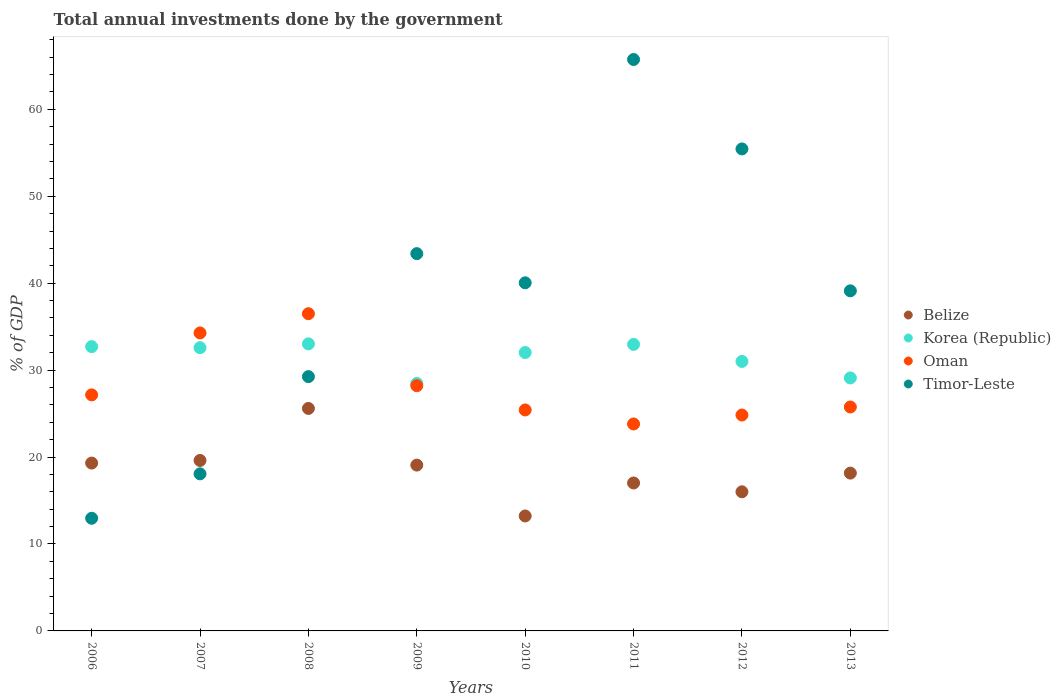What is the total annual investments done by the government in Korea (Republic) in 2007?
Provide a short and direct response. 32.58. Across all years, what is the maximum total annual investments done by the government in Belize?
Your answer should be very brief. 25.59. Across all years, what is the minimum total annual investments done by the government in Belize?
Your answer should be compact. 13.22. In which year was the total annual investments done by the government in Timor-Leste minimum?
Your answer should be compact. 2006. What is the total total annual investments done by the government in Belize in the graph?
Provide a succinct answer. 147.98. What is the difference between the total annual investments done by the government in Belize in 2006 and that in 2010?
Offer a very short reply. 6.08. What is the difference between the total annual investments done by the government in Timor-Leste in 2013 and the total annual investments done by the government in Korea (Republic) in 2009?
Provide a succinct answer. 10.65. What is the average total annual investments done by the government in Korea (Republic) per year?
Give a very brief answer. 31.48. In the year 2011, what is the difference between the total annual investments done by the government in Oman and total annual investments done by the government in Timor-Leste?
Keep it short and to the point. -41.92. In how many years, is the total annual investments done by the government in Belize greater than 24 %?
Provide a succinct answer. 1. What is the ratio of the total annual investments done by the government in Oman in 2010 to that in 2013?
Your answer should be compact. 0.99. Is the total annual investments done by the government in Korea (Republic) in 2012 less than that in 2013?
Your response must be concise. No. Is the difference between the total annual investments done by the government in Oman in 2009 and 2011 greater than the difference between the total annual investments done by the government in Timor-Leste in 2009 and 2011?
Your answer should be very brief. Yes. What is the difference between the highest and the second highest total annual investments done by the government in Timor-Leste?
Keep it short and to the point. 10.29. What is the difference between the highest and the lowest total annual investments done by the government in Timor-Leste?
Offer a terse response. 52.77. Is the total annual investments done by the government in Oman strictly greater than the total annual investments done by the government in Timor-Leste over the years?
Your answer should be compact. No. How many dotlines are there?
Your answer should be very brief. 4. Does the graph contain any zero values?
Ensure brevity in your answer.  No. How are the legend labels stacked?
Your answer should be compact. Vertical. What is the title of the graph?
Ensure brevity in your answer.  Total annual investments done by the government. Does "Sub-Saharan Africa (all income levels)" appear as one of the legend labels in the graph?
Ensure brevity in your answer.  No. What is the label or title of the X-axis?
Your answer should be compact. Years. What is the label or title of the Y-axis?
Offer a terse response. % of GDP. What is the % of GDP in Belize in 2006?
Make the answer very short. 19.31. What is the % of GDP of Korea (Republic) in 2006?
Your answer should be very brief. 32.7. What is the % of GDP of Oman in 2006?
Provide a short and direct response. 27.15. What is the % of GDP in Timor-Leste in 2006?
Give a very brief answer. 12.96. What is the % of GDP of Belize in 2007?
Provide a short and direct response. 19.61. What is the % of GDP of Korea (Republic) in 2007?
Your answer should be compact. 32.58. What is the % of GDP in Oman in 2007?
Your answer should be very brief. 34.28. What is the % of GDP of Timor-Leste in 2007?
Provide a succinct answer. 18.07. What is the % of GDP in Belize in 2008?
Offer a very short reply. 25.59. What is the % of GDP in Korea (Republic) in 2008?
Your response must be concise. 33.02. What is the % of GDP in Oman in 2008?
Give a very brief answer. 36.49. What is the % of GDP of Timor-Leste in 2008?
Make the answer very short. 29.25. What is the % of GDP in Belize in 2009?
Your answer should be very brief. 19.08. What is the % of GDP of Korea (Republic) in 2009?
Give a very brief answer. 28.47. What is the % of GDP of Oman in 2009?
Offer a very short reply. 28.21. What is the % of GDP in Timor-Leste in 2009?
Keep it short and to the point. 43.4. What is the % of GDP in Belize in 2010?
Provide a succinct answer. 13.22. What is the % of GDP in Korea (Republic) in 2010?
Keep it short and to the point. 32.02. What is the % of GDP of Oman in 2010?
Your answer should be very brief. 25.42. What is the % of GDP of Timor-Leste in 2010?
Provide a short and direct response. 40.04. What is the % of GDP in Belize in 2011?
Provide a short and direct response. 17.02. What is the % of GDP in Korea (Republic) in 2011?
Provide a succinct answer. 32.96. What is the % of GDP of Oman in 2011?
Ensure brevity in your answer.  23.8. What is the % of GDP of Timor-Leste in 2011?
Ensure brevity in your answer.  65.73. What is the % of GDP of Belize in 2012?
Make the answer very short. 16. What is the % of GDP of Korea (Republic) in 2012?
Give a very brief answer. 31. What is the % of GDP in Oman in 2012?
Give a very brief answer. 24.83. What is the % of GDP of Timor-Leste in 2012?
Your answer should be very brief. 55.44. What is the % of GDP of Belize in 2013?
Your answer should be very brief. 18.15. What is the % of GDP in Korea (Republic) in 2013?
Provide a short and direct response. 29.1. What is the % of GDP of Oman in 2013?
Offer a terse response. 25.76. What is the % of GDP of Timor-Leste in 2013?
Your answer should be very brief. 39.12. Across all years, what is the maximum % of GDP in Belize?
Your answer should be very brief. 25.59. Across all years, what is the maximum % of GDP of Korea (Republic)?
Keep it short and to the point. 33.02. Across all years, what is the maximum % of GDP of Oman?
Your answer should be very brief. 36.49. Across all years, what is the maximum % of GDP of Timor-Leste?
Your answer should be compact. 65.73. Across all years, what is the minimum % of GDP in Belize?
Offer a very short reply. 13.22. Across all years, what is the minimum % of GDP of Korea (Republic)?
Your answer should be very brief. 28.47. Across all years, what is the minimum % of GDP in Oman?
Keep it short and to the point. 23.8. Across all years, what is the minimum % of GDP in Timor-Leste?
Give a very brief answer. 12.96. What is the total % of GDP of Belize in the graph?
Your answer should be compact. 147.98. What is the total % of GDP in Korea (Republic) in the graph?
Ensure brevity in your answer.  251.85. What is the total % of GDP of Oman in the graph?
Your response must be concise. 225.94. What is the total % of GDP of Timor-Leste in the graph?
Ensure brevity in your answer.  304.01. What is the difference between the % of GDP in Belize in 2006 and that in 2007?
Ensure brevity in your answer.  -0.3. What is the difference between the % of GDP in Korea (Republic) in 2006 and that in 2007?
Offer a terse response. 0.12. What is the difference between the % of GDP of Oman in 2006 and that in 2007?
Your response must be concise. -7.13. What is the difference between the % of GDP in Timor-Leste in 2006 and that in 2007?
Your answer should be very brief. -5.11. What is the difference between the % of GDP in Belize in 2006 and that in 2008?
Offer a very short reply. -6.28. What is the difference between the % of GDP of Korea (Republic) in 2006 and that in 2008?
Your answer should be compact. -0.32. What is the difference between the % of GDP in Oman in 2006 and that in 2008?
Offer a very short reply. -9.34. What is the difference between the % of GDP in Timor-Leste in 2006 and that in 2008?
Your response must be concise. -16.29. What is the difference between the % of GDP of Belize in 2006 and that in 2009?
Your answer should be very brief. 0.23. What is the difference between the % of GDP in Korea (Republic) in 2006 and that in 2009?
Make the answer very short. 4.24. What is the difference between the % of GDP in Oman in 2006 and that in 2009?
Your answer should be very brief. -1.06. What is the difference between the % of GDP of Timor-Leste in 2006 and that in 2009?
Ensure brevity in your answer.  -30.44. What is the difference between the % of GDP in Belize in 2006 and that in 2010?
Ensure brevity in your answer.  6.08. What is the difference between the % of GDP of Korea (Republic) in 2006 and that in 2010?
Provide a succinct answer. 0.68. What is the difference between the % of GDP of Oman in 2006 and that in 2010?
Keep it short and to the point. 1.73. What is the difference between the % of GDP in Timor-Leste in 2006 and that in 2010?
Ensure brevity in your answer.  -27.08. What is the difference between the % of GDP of Belize in 2006 and that in 2011?
Provide a succinct answer. 2.29. What is the difference between the % of GDP in Korea (Republic) in 2006 and that in 2011?
Your response must be concise. -0.26. What is the difference between the % of GDP of Oman in 2006 and that in 2011?
Provide a succinct answer. 3.35. What is the difference between the % of GDP of Timor-Leste in 2006 and that in 2011?
Keep it short and to the point. -52.77. What is the difference between the % of GDP of Belize in 2006 and that in 2012?
Make the answer very short. 3.31. What is the difference between the % of GDP in Korea (Republic) in 2006 and that in 2012?
Offer a very short reply. 1.7. What is the difference between the % of GDP in Oman in 2006 and that in 2012?
Give a very brief answer. 2.32. What is the difference between the % of GDP of Timor-Leste in 2006 and that in 2012?
Keep it short and to the point. -42.49. What is the difference between the % of GDP of Belize in 2006 and that in 2013?
Offer a terse response. 1.15. What is the difference between the % of GDP in Korea (Republic) in 2006 and that in 2013?
Provide a short and direct response. 3.6. What is the difference between the % of GDP in Oman in 2006 and that in 2013?
Offer a terse response. 1.39. What is the difference between the % of GDP of Timor-Leste in 2006 and that in 2013?
Make the answer very short. -26.16. What is the difference between the % of GDP of Belize in 2007 and that in 2008?
Offer a very short reply. -5.98. What is the difference between the % of GDP in Korea (Republic) in 2007 and that in 2008?
Make the answer very short. -0.44. What is the difference between the % of GDP in Oman in 2007 and that in 2008?
Offer a terse response. -2.21. What is the difference between the % of GDP in Timor-Leste in 2007 and that in 2008?
Offer a very short reply. -11.18. What is the difference between the % of GDP in Belize in 2007 and that in 2009?
Offer a very short reply. 0.53. What is the difference between the % of GDP of Korea (Republic) in 2007 and that in 2009?
Provide a short and direct response. 4.11. What is the difference between the % of GDP in Oman in 2007 and that in 2009?
Keep it short and to the point. 6.07. What is the difference between the % of GDP in Timor-Leste in 2007 and that in 2009?
Provide a succinct answer. -25.33. What is the difference between the % of GDP of Belize in 2007 and that in 2010?
Offer a very short reply. 6.39. What is the difference between the % of GDP of Korea (Republic) in 2007 and that in 2010?
Provide a succinct answer. 0.56. What is the difference between the % of GDP in Oman in 2007 and that in 2010?
Ensure brevity in your answer.  8.86. What is the difference between the % of GDP in Timor-Leste in 2007 and that in 2010?
Provide a short and direct response. -21.97. What is the difference between the % of GDP of Belize in 2007 and that in 2011?
Provide a short and direct response. 2.59. What is the difference between the % of GDP in Korea (Republic) in 2007 and that in 2011?
Your response must be concise. -0.38. What is the difference between the % of GDP of Oman in 2007 and that in 2011?
Ensure brevity in your answer.  10.47. What is the difference between the % of GDP of Timor-Leste in 2007 and that in 2011?
Offer a very short reply. -47.66. What is the difference between the % of GDP of Belize in 2007 and that in 2012?
Your answer should be very brief. 3.61. What is the difference between the % of GDP of Korea (Republic) in 2007 and that in 2012?
Ensure brevity in your answer.  1.58. What is the difference between the % of GDP in Oman in 2007 and that in 2012?
Provide a succinct answer. 9.44. What is the difference between the % of GDP of Timor-Leste in 2007 and that in 2012?
Your answer should be compact. -37.38. What is the difference between the % of GDP of Belize in 2007 and that in 2013?
Your response must be concise. 1.45. What is the difference between the % of GDP of Korea (Republic) in 2007 and that in 2013?
Ensure brevity in your answer.  3.48. What is the difference between the % of GDP in Oman in 2007 and that in 2013?
Offer a very short reply. 8.52. What is the difference between the % of GDP of Timor-Leste in 2007 and that in 2013?
Ensure brevity in your answer.  -21.05. What is the difference between the % of GDP of Belize in 2008 and that in 2009?
Your answer should be compact. 6.52. What is the difference between the % of GDP in Korea (Republic) in 2008 and that in 2009?
Provide a short and direct response. 4.55. What is the difference between the % of GDP of Oman in 2008 and that in 2009?
Provide a succinct answer. 8.28. What is the difference between the % of GDP of Timor-Leste in 2008 and that in 2009?
Provide a short and direct response. -14.15. What is the difference between the % of GDP of Belize in 2008 and that in 2010?
Your answer should be compact. 12.37. What is the difference between the % of GDP in Korea (Republic) in 2008 and that in 2010?
Offer a terse response. 1. What is the difference between the % of GDP of Oman in 2008 and that in 2010?
Your response must be concise. 11.07. What is the difference between the % of GDP in Timor-Leste in 2008 and that in 2010?
Your answer should be very brief. -10.79. What is the difference between the % of GDP of Belize in 2008 and that in 2011?
Offer a terse response. 8.57. What is the difference between the % of GDP in Korea (Republic) in 2008 and that in 2011?
Provide a short and direct response. 0.06. What is the difference between the % of GDP of Oman in 2008 and that in 2011?
Keep it short and to the point. 12.68. What is the difference between the % of GDP of Timor-Leste in 2008 and that in 2011?
Your answer should be compact. -36.48. What is the difference between the % of GDP in Belize in 2008 and that in 2012?
Give a very brief answer. 9.59. What is the difference between the % of GDP in Korea (Republic) in 2008 and that in 2012?
Ensure brevity in your answer.  2.02. What is the difference between the % of GDP in Oman in 2008 and that in 2012?
Make the answer very short. 11.65. What is the difference between the % of GDP of Timor-Leste in 2008 and that in 2012?
Provide a short and direct response. -26.19. What is the difference between the % of GDP of Belize in 2008 and that in 2013?
Ensure brevity in your answer.  7.44. What is the difference between the % of GDP in Korea (Republic) in 2008 and that in 2013?
Keep it short and to the point. 3.92. What is the difference between the % of GDP in Oman in 2008 and that in 2013?
Keep it short and to the point. 10.73. What is the difference between the % of GDP of Timor-Leste in 2008 and that in 2013?
Keep it short and to the point. -9.87. What is the difference between the % of GDP of Belize in 2009 and that in 2010?
Offer a very short reply. 5.85. What is the difference between the % of GDP in Korea (Republic) in 2009 and that in 2010?
Your answer should be compact. -3.56. What is the difference between the % of GDP in Oman in 2009 and that in 2010?
Keep it short and to the point. 2.79. What is the difference between the % of GDP of Timor-Leste in 2009 and that in 2010?
Your response must be concise. 3.36. What is the difference between the % of GDP in Belize in 2009 and that in 2011?
Make the answer very short. 2.06. What is the difference between the % of GDP in Korea (Republic) in 2009 and that in 2011?
Make the answer very short. -4.49. What is the difference between the % of GDP of Oman in 2009 and that in 2011?
Offer a terse response. 4.4. What is the difference between the % of GDP in Timor-Leste in 2009 and that in 2011?
Provide a short and direct response. -22.33. What is the difference between the % of GDP in Belize in 2009 and that in 2012?
Make the answer very short. 3.07. What is the difference between the % of GDP in Korea (Republic) in 2009 and that in 2012?
Your answer should be very brief. -2.54. What is the difference between the % of GDP of Oman in 2009 and that in 2012?
Your answer should be very brief. 3.37. What is the difference between the % of GDP of Timor-Leste in 2009 and that in 2012?
Keep it short and to the point. -12.05. What is the difference between the % of GDP in Belize in 2009 and that in 2013?
Provide a short and direct response. 0.92. What is the difference between the % of GDP in Korea (Republic) in 2009 and that in 2013?
Keep it short and to the point. -0.64. What is the difference between the % of GDP of Oman in 2009 and that in 2013?
Make the answer very short. 2.45. What is the difference between the % of GDP of Timor-Leste in 2009 and that in 2013?
Give a very brief answer. 4.28. What is the difference between the % of GDP in Belize in 2010 and that in 2011?
Provide a short and direct response. -3.8. What is the difference between the % of GDP of Korea (Republic) in 2010 and that in 2011?
Your answer should be very brief. -0.94. What is the difference between the % of GDP of Oman in 2010 and that in 2011?
Provide a short and direct response. 1.61. What is the difference between the % of GDP in Timor-Leste in 2010 and that in 2011?
Offer a very short reply. -25.69. What is the difference between the % of GDP in Belize in 2010 and that in 2012?
Provide a succinct answer. -2.78. What is the difference between the % of GDP of Korea (Republic) in 2010 and that in 2012?
Offer a terse response. 1.02. What is the difference between the % of GDP of Oman in 2010 and that in 2012?
Provide a succinct answer. 0.58. What is the difference between the % of GDP in Timor-Leste in 2010 and that in 2012?
Keep it short and to the point. -15.4. What is the difference between the % of GDP in Belize in 2010 and that in 2013?
Offer a terse response. -4.93. What is the difference between the % of GDP of Korea (Republic) in 2010 and that in 2013?
Make the answer very short. 2.92. What is the difference between the % of GDP of Oman in 2010 and that in 2013?
Give a very brief answer. -0.34. What is the difference between the % of GDP of Timor-Leste in 2010 and that in 2013?
Keep it short and to the point. 0.92. What is the difference between the % of GDP in Belize in 2011 and that in 2012?
Ensure brevity in your answer.  1.02. What is the difference between the % of GDP in Korea (Republic) in 2011 and that in 2012?
Your response must be concise. 1.96. What is the difference between the % of GDP of Oman in 2011 and that in 2012?
Keep it short and to the point. -1.03. What is the difference between the % of GDP in Timor-Leste in 2011 and that in 2012?
Ensure brevity in your answer.  10.29. What is the difference between the % of GDP of Belize in 2011 and that in 2013?
Ensure brevity in your answer.  -1.14. What is the difference between the % of GDP of Korea (Republic) in 2011 and that in 2013?
Offer a very short reply. 3.86. What is the difference between the % of GDP in Oman in 2011 and that in 2013?
Provide a succinct answer. -1.95. What is the difference between the % of GDP of Timor-Leste in 2011 and that in 2013?
Your answer should be very brief. 26.61. What is the difference between the % of GDP of Belize in 2012 and that in 2013?
Provide a succinct answer. -2.15. What is the difference between the % of GDP in Korea (Republic) in 2012 and that in 2013?
Keep it short and to the point. 1.9. What is the difference between the % of GDP of Oman in 2012 and that in 2013?
Ensure brevity in your answer.  -0.93. What is the difference between the % of GDP in Timor-Leste in 2012 and that in 2013?
Your answer should be very brief. 16.32. What is the difference between the % of GDP in Belize in 2006 and the % of GDP in Korea (Republic) in 2007?
Keep it short and to the point. -13.27. What is the difference between the % of GDP in Belize in 2006 and the % of GDP in Oman in 2007?
Offer a terse response. -14.97. What is the difference between the % of GDP in Belize in 2006 and the % of GDP in Timor-Leste in 2007?
Your answer should be very brief. 1.24. What is the difference between the % of GDP of Korea (Republic) in 2006 and the % of GDP of Oman in 2007?
Your response must be concise. -1.58. What is the difference between the % of GDP of Korea (Republic) in 2006 and the % of GDP of Timor-Leste in 2007?
Provide a succinct answer. 14.63. What is the difference between the % of GDP of Oman in 2006 and the % of GDP of Timor-Leste in 2007?
Provide a succinct answer. 9.08. What is the difference between the % of GDP of Belize in 2006 and the % of GDP of Korea (Republic) in 2008?
Your response must be concise. -13.71. What is the difference between the % of GDP in Belize in 2006 and the % of GDP in Oman in 2008?
Offer a terse response. -17.18. What is the difference between the % of GDP of Belize in 2006 and the % of GDP of Timor-Leste in 2008?
Offer a terse response. -9.94. What is the difference between the % of GDP of Korea (Republic) in 2006 and the % of GDP of Oman in 2008?
Your answer should be very brief. -3.79. What is the difference between the % of GDP of Korea (Republic) in 2006 and the % of GDP of Timor-Leste in 2008?
Keep it short and to the point. 3.45. What is the difference between the % of GDP of Oman in 2006 and the % of GDP of Timor-Leste in 2008?
Provide a short and direct response. -2.1. What is the difference between the % of GDP in Belize in 2006 and the % of GDP in Korea (Republic) in 2009?
Make the answer very short. -9.16. What is the difference between the % of GDP in Belize in 2006 and the % of GDP in Oman in 2009?
Your answer should be compact. -8.9. What is the difference between the % of GDP in Belize in 2006 and the % of GDP in Timor-Leste in 2009?
Provide a short and direct response. -24.09. What is the difference between the % of GDP of Korea (Republic) in 2006 and the % of GDP of Oman in 2009?
Give a very brief answer. 4.49. What is the difference between the % of GDP of Korea (Republic) in 2006 and the % of GDP of Timor-Leste in 2009?
Keep it short and to the point. -10.7. What is the difference between the % of GDP in Oman in 2006 and the % of GDP in Timor-Leste in 2009?
Your answer should be compact. -16.25. What is the difference between the % of GDP of Belize in 2006 and the % of GDP of Korea (Republic) in 2010?
Give a very brief answer. -12.71. What is the difference between the % of GDP of Belize in 2006 and the % of GDP of Oman in 2010?
Ensure brevity in your answer.  -6.11. What is the difference between the % of GDP of Belize in 2006 and the % of GDP of Timor-Leste in 2010?
Provide a short and direct response. -20.73. What is the difference between the % of GDP in Korea (Republic) in 2006 and the % of GDP in Oman in 2010?
Offer a very short reply. 7.28. What is the difference between the % of GDP of Korea (Republic) in 2006 and the % of GDP of Timor-Leste in 2010?
Give a very brief answer. -7.34. What is the difference between the % of GDP of Oman in 2006 and the % of GDP of Timor-Leste in 2010?
Offer a very short reply. -12.89. What is the difference between the % of GDP of Belize in 2006 and the % of GDP of Korea (Republic) in 2011?
Keep it short and to the point. -13.65. What is the difference between the % of GDP of Belize in 2006 and the % of GDP of Oman in 2011?
Make the answer very short. -4.5. What is the difference between the % of GDP in Belize in 2006 and the % of GDP in Timor-Leste in 2011?
Provide a short and direct response. -46.42. What is the difference between the % of GDP in Korea (Republic) in 2006 and the % of GDP in Oman in 2011?
Offer a very short reply. 8.9. What is the difference between the % of GDP in Korea (Republic) in 2006 and the % of GDP in Timor-Leste in 2011?
Offer a very short reply. -33.03. What is the difference between the % of GDP of Oman in 2006 and the % of GDP of Timor-Leste in 2011?
Provide a succinct answer. -38.58. What is the difference between the % of GDP in Belize in 2006 and the % of GDP in Korea (Republic) in 2012?
Provide a succinct answer. -11.69. What is the difference between the % of GDP in Belize in 2006 and the % of GDP in Oman in 2012?
Provide a succinct answer. -5.53. What is the difference between the % of GDP of Belize in 2006 and the % of GDP of Timor-Leste in 2012?
Offer a very short reply. -36.14. What is the difference between the % of GDP of Korea (Republic) in 2006 and the % of GDP of Oman in 2012?
Provide a short and direct response. 7.87. What is the difference between the % of GDP of Korea (Republic) in 2006 and the % of GDP of Timor-Leste in 2012?
Give a very brief answer. -22.74. What is the difference between the % of GDP of Oman in 2006 and the % of GDP of Timor-Leste in 2012?
Provide a succinct answer. -28.29. What is the difference between the % of GDP in Belize in 2006 and the % of GDP in Korea (Republic) in 2013?
Give a very brief answer. -9.79. What is the difference between the % of GDP in Belize in 2006 and the % of GDP in Oman in 2013?
Give a very brief answer. -6.45. What is the difference between the % of GDP of Belize in 2006 and the % of GDP of Timor-Leste in 2013?
Provide a short and direct response. -19.81. What is the difference between the % of GDP in Korea (Republic) in 2006 and the % of GDP in Oman in 2013?
Provide a succinct answer. 6.94. What is the difference between the % of GDP in Korea (Republic) in 2006 and the % of GDP in Timor-Leste in 2013?
Your answer should be very brief. -6.42. What is the difference between the % of GDP of Oman in 2006 and the % of GDP of Timor-Leste in 2013?
Your answer should be compact. -11.97. What is the difference between the % of GDP in Belize in 2007 and the % of GDP in Korea (Republic) in 2008?
Your response must be concise. -13.41. What is the difference between the % of GDP of Belize in 2007 and the % of GDP of Oman in 2008?
Ensure brevity in your answer.  -16.88. What is the difference between the % of GDP of Belize in 2007 and the % of GDP of Timor-Leste in 2008?
Your response must be concise. -9.64. What is the difference between the % of GDP in Korea (Republic) in 2007 and the % of GDP in Oman in 2008?
Ensure brevity in your answer.  -3.91. What is the difference between the % of GDP in Korea (Republic) in 2007 and the % of GDP in Timor-Leste in 2008?
Provide a short and direct response. 3.33. What is the difference between the % of GDP in Oman in 2007 and the % of GDP in Timor-Leste in 2008?
Your answer should be very brief. 5.03. What is the difference between the % of GDP of Belize in 2007 and the % of GDP of Korea (Republic) in 2009?
Provide a succinct answer. -8.86. What is the difference between the % of GDP of Belize in 2007 and the % of GDP of Oman in 2009?
Offer a terse response. -8.6. What is the difference between the % of GDP of Belize in 2007 and the % of GDP of Timor-Leste in 2009?
Offer a terse response. -23.79. What is the difference between the % of GDP in Korea (Republic) in 2007 and the % of GDP in Oman in 2009?
Your answer should be very brief. 4.37. What is the difference between the % of GDP in Korea (Republic) in 2007 and the % of GDP in Timor-Leste in 2009?
Keep it short and to the point. -10.82. What is the difference between the % of GDP of Oman in 2007 and the % of GDP of Timor-Leste in 2009?
Make the answer very short. -9.12. What is the difference between the % of GDP in Belize in 2007 and the % of GDP in Korea (Republic) in 2010?
Offer a very short reply. -12.41. What is the difference between the % of GDP in Belize in 2007 and the % of GDP in Oman in 2010?
Make the answer very short. -5.81. What is the difference between the % of GDP of Belize in 2007 and the % of GDP of Timor-Leste in 2010?
Ensure brevity in your answer.  -20.43. What is the difference between the % of GDP in Korea (Republic) in 2007 and the % of GDP in Oman in 2010?
Ensure brevity in your answer.  7.16. What is the difference between the % of GDP in Korea (Republic) in 2007 and the % of GDP in Timor-Leste in 2010?
Your answer should be compact. -7.46. What is the difference between the % of GDP in Oman in 2007 and the % of GDP in Timor-Leste in 2010?
Your answer should be very brief. -5.77. What is the difference between the % of GDP in Belize in 2007 and the % of GDP in Korea (Republic) in 2011?
Provide a short and direct response. -13.35. What is the difference between the % of GDP of Belize in 2007 and the % of GDP of Oman in 2011?
Give a very brief answer. -4.2. What is the difference between the % of GDP of Belize in 2007 and the % of GDP of Timor-Leste in 2011?
Ensure brevity in your answer.  -46.12. What is the difference between the % of GDP in Korea (Republic) in 2007 and the % of GDP in Oman in 2011?
Provide a succinct answer. 8.77. What is the difference between the % of GDP in Korea (Republic) in 2007 and the % of GDP in Timor-Leste in 2011?
Provide a succinct answer. -33.15. What is the difference between the % of GDP of Oman in 2007 and the % of GDP of Timor-Leste in 2011?
Your answer should be compact. -31.45. What is the difference between the % of GDP in Belize in 2007 and the % of GDP in Korea (Republic) in 2012?
Provide a succinct answer. -11.39. What is the difference between the % of GDP of Belize in 2007 and the % of GDP of Oman in 2012?
Your response must be concise. -5.23. What is the difference between the % of GDP of Belize in 2007 and the % of GDP of Timor-Leste in 2012?
Your answer should be very brief. -35.84. What is the difference between the % of GDP in Korea (Republic) in 2007 and the % of GDP in Oman in 2012?
Provide a short and direct response. 7.75. What is the difference between the % of GDP in Korea (Republic) in 2007 and the % of GDP in Timor-Leste in 2012?
Your response must be concise. -22.86. What is the difference between the % of GDP of Oman in 2007 and the % of GDP of Timor-Leste in 2012?
Offer a terse response. -21.17. What is the difference between the % of GDP of Belize in 2007 and the % of GDP of Korea (Republic) in 2013?
Provide a succinct answer. -9.49. What is the difference between the % of GDP in Belize in 2007 and the % of GDP in Oman in 2013?
Give a very brief answer. -6.15. What is the difference between the % of GDP of Belize in 2007 and the % of GDP of Timor-Leste in 2013?
Provide a succinct answer. -19.51. What is the difference between the % of GDP in Korea (Republic) in 2007 and the % of GDP in Oman in 2013?
Your response must be concise. 6.82. What is the difference between the % of GDP of Korea (Republic) in 2007 and the % of GDP of Timor-Leste in 2013?
Offer a terse response. -6.54. What is the difference between the % of GDP of Oman in 2007 and the % of GDP of Timor-Leste in 2013?
Ensure brevity in your answer.  -4.84. What is the difference between the % of GDP of Belize in 2008 and the % of GDP of Korea (Republic) in 2009?
Your answer should be compact. -2.87. What is the difference between the % of GDP of Belize in 2008 and the % of GDP of Oman in 2009?
Offer a terse response. -2.61. What is the difference between the % of GDP in Belize in 2008 and the % of GDP in Timor-Leste in 2009?
Offer a terse response. -17.81. What is the difference between the % of GDP in Korea (Republic) in 2008 and the % of GDP in Oman in 2009?
Offer a very short reply. 4.81. What is the difference between the % of GDP in Korea (Republic) in 2008 and the % of GDP in Timor-Leste in 2009?
Your answer should be compact. -10.38. What is the difference between the % of GDP in Oman in 2008 and the % of GDP in Timor-Leste in 2009?
Ensure brevity in your answer.  -6.91. What is the difference between the % of GDP in Belize in 2008 and the % of GDP in Korea (Republic) in 2010?
Keep it short and to the point. -6.43. What is the difference between the % of GDP in Belize in 2008 and the % of GDP in Oman in 2010?
Your response must be concise. 0.17. What is the difference between the % of GDP of Belize in 2008 and the % of GDP of Timor-Leste in 2010?
Provide a succinct answer. -14.45. What is the difference between the % of GDP in Korea (Republic) in 2008 and the % of GDP in Oman in 2010?
Your answer should be compact. 7.6. What is the difference between the % of GDP of Korea (Republic) in 2008 and the % of GDP of Timor-Leste in 2010?
Ensure brevity in your answer.  -7.02. What is the difference between the % of GDP of Oman in 2008 and the % of GDP of Timor-Leste in 2010?
Your response must be concise. -3.55. What is the difference between the % of GDP in Belize in 2008 and the % of GDP in Korea (Republic) in 2011?
Make the answer very short. -7.37. What is the difference between the % of GDP of Belize in 2008 and the % of GDP of Oman in 2011?
Give a very brief answer. 1.79. What is the difference between the % of GDP in Belize in 2008 and the % of GDP in Timor-Leste in 2011?
Your response must be concise. -40.14. What is the difference between the % of GDP of Korea (Republic) in 2008 and the % of GDP of Oman in 2011?
Your answer should be compact. 9.21. What is the difference between the % of GDP in Korea (Republic) in 2008 and the % of GDP in Timor-Leste in 2011?
Offer a terse response. -32.71. What is the difference between the % of GDP in Oman in 2008 and the % of GDP in Timor-Leste in 2011?
Your response must be concise. -29.24. What is the difference between the % of GDP of Belize in 2008 and the % of GDP of Korea (Republic) in 2012?
Keep it short and to the point. -5.41. What is the difference between the % of GDP of Belize in 2008 and the % of GDP of Oman in 2012?
Offer a very short reply. 0.76. What is the difference between the % of GDP in Belize in 2008 and the % of GDP in Timor-Leste in 2012?
Give a very brief answer. -29.85. What is the difference between the % of GDP of Korea (Republic) in 2008 and the % of GDP of Oman in 2012?
Your response must be concise. 8.18. What is the difference between the % of GDP of Korea (Republic) in 2008 and the % of GDP of Timor-Leste in 2012?
Provide a succinct answer. -22.43. What is the difference between the % of GDP in Oman in 2008 and the % of GDP in Timor-Leste in 2012?
Make the answer very short. -18.96. What is the difference between the % of GDP in Belize in 2008 and the % of GDP in Korea (Republic) in 2013?
Make the answer very short. -3.51. What is the difference between the % of GDP in Belize in 2008 and the % of GDP in Oman in 2013?
Your answer should be compact. -0.17. What is the difference between the % of GDP in Belize in 2008 and the % of GDP in Timor-Leste in 2013?
Ensure brevity in your answer.  -13.53. What is the difference between the % of GDP of Korea (Republic) in 2008 and the % of GDP of Oman in 2013?
Ensure brevity in your answer.  7.26. What is the difference between the % of GDP of Korea (Republic) in 2008 and the % of GDP of Timor-Leste in 2013?
Your response must be concise. -6.1. What is the difference between the % of GDP of Oman in 2008 and the % of GDP of Timor-Leste in 2013?
Provide a succinct answer. -2.63. What is the difference between the % of GDP in Belize in 2009 and the % of GDP in Korea (Republic) in 2010?
Make the answer very short. -12.95. What is the difference between the % of GDP of Belize in 2009 and the % of GDP of Oman in 2010?
Your response must be concise. -6.34. What is the difference between the % of GDP in Belize in 2009 and the % of GDP in Timor-Leste in 2010?
Offer a very short reply. -20.97. What is the difference between the % of GDP in Korea (Republic) in 2009 and the % of GDP in Oman in 2010?
Provide a succinct answer. 3.05. What is the difference between the % of GDP of Korea (Republic) in 2009 and the % of GDP of Timor-Leste in 2010?
Offer a terse response. -11.58. What is the difference between the % of GDP in Oman in 2009 and the % of GDP in Timor-Leste in 2010?
Provide a short and direct response. -11.84. What is the difference between the % of GDP of Belize in 2009 and the % of GDP of Korea (Republic) in 2011?
Ensure brevity in your answer.  -13.88. What is the difference between the % of GDP in Belize in 2009 and the % of GDP in Oman in 2011?
Make the answer very short. -4.73. What is the difference between the % of GDP in Belize in 2009 and the % of GDP in Timor-Leste in 2011?
Provide a short and direct response. -46.65. What is the difference between the % of GDP in Korea (Republic) in 2009 and the % of GDP in Oman in 2011?
Your response must be concise. 4.66. What is the difference between the % of GDP in Korea (Republic) in 2009 and the % of GDP in Timor-Leste in 2011?
Your answer should be very brief. -37.26. What is the difference between the % of GDP in Oman in 2009 and the % of GDP in Timor-Leste in 2011?
Your response must be concise. -37.52. What is the difference between the % of GDP in Belize in 2009 and the % of GDP in Korea (Republic) in 2012?
Give a very brief answer. -11.93. What is the difference between the % of GDP in Belize in 2009 and the % of GDP in Oman in 2012?
Keep it short and to the point. -5.76. What is the difference between the % of GDP in Belize in 2009 and the % of GDP in Timor-Leste in 2012?
Your response must be concise. -36.37. What is the difference between the % of GDP of Korea (Republic) in 2009 and the % of GDP of Oman in 2012?
Offer a terse response. 3.63. What is the difference between the % of GDP of Korea (Republic) in 2009 and the % of GDP of Timor-Leste in 2012?
Offer a terse response. -26.98. What is the difference between the % of GDP of Oman in 2009 and the % of GDP of Timor-Leste in 2012?
Provide a short and direct response. -27.24. What is the difference between the % of GDP in Belize in 2009 and the % of GDP in Korea (Republic) in 2013?
Give a very brief answer. -10.03. What is the difference between the % of GDP in Belize in 2009 and the % of GDP in Oman in 2013?
Ensure brevity in your answer.  -6.68. What is the difference between the % of GDP in Belize in 2009 and the % of GDP in Timor-Leste in 2013?
Offer a terse response. -20.05. What is the difference between the % of GDP of Korea (Republic) in 2009 and the % of GDP of Oman in 2013?
Provide a succinct answer. 2.71. What is the difference between the % of GDP in Korea (Republic) in 2009 and the % of GDP in Timor-Leste in 2013?
Make the answer very short. -10.65. What is the difference between the % of GDP of Oman in 2009 and the % of GDP of Timor-Leste in 2013?
Your answer should be compact. -10.91. What is the difference between the % of GDP in Belize in 2010 and the % of GDP in Korea (Republic) in 2011?
Offer a terse response. -19.74. What is the difference between the % of GDP of Belize in 2010 and the % of GDP of Oman in 2011?
Make the answer very short. -10.58. What is the difference between the % of GDP in Belize in 2010 and the % of GDP in Timor-Leste in 2011?
Give a very brief answer. -52.51. What is the difference between the % of GDP of Korea (Republic) in 2010 and the % of GDP of Oman in 2011?
Ensure brevity in your answer.  8.22. What is the difference between the % of GDP of Korea (Republic) in 2010 and the % of GDP of Timor-Leste in 2011?
Give a very brief answer. -33.71. What is the difference between the % of GDP in Oman in 2010 and the % of GDP in Timor-Leste in 2011?
Your answer should be very brief. -40.31. What is the difference between the % of GDP of Belize in 2010 and the % of GDP of Korea (Republic) in 2012?
Your response must be concise. -17.78. What is the difference between the % of GDP of Belize in 2010 and the % of GDP of Oman in 2012?
Offer a terse response. -11.61. What is the difference between the % of GDP in Belize in 2010 and the % of GDP in Timor-Leste in 2012?
Ensure brevity in your answer.  -42.22. What is the difference between the % of GDP in Korea (Republic) in 2010 and the % of GDP in Oman in 2012?
Your response must be concise. 7.19. What is the difference between the % of GDP in Korea (Republic) in 2010 and the % of GDP in Timor-Leste in 2012?
Offer a terse response. -23.42. What is the difference between the % of GDP in Oman in 2010 and the % of GDP in Timor-Leste in 2012?
Provide a succinct answer. -30.03. What is the difference between the % of GDP of Belize in 2010 and the % of GDP of Korea (Republic) in 2013?
Provide a succinct answer. -15.88. What is the difference between the % of GDP in Belize in 2010 and the % of GDP in Oman in 2013?
Your response must be concise. -12.54. What is the difference between the % of GDP of Belize in 2010 and the % of GDP of Timor-Leste in 2013?
Your response must be concise. -25.9. What is the difference between the % of GDP of Korea (Republic) in 2010 and the % of GDP of Oman in 2013?
Your answer should be very brief. 6.26. What is the difference between the % of GDP of Korea (Republic) in 2010 and the % of GDP of Timor-Leste in 2013?
Your answer should be very brief. -7.1. What is the difference between the % of GDP of Oman in 2010 and the % of GDP of Timor-Leste in 2013?
Provide a short and direct response. -13.7. What is the difference between the % of GDP in Belize in 2011 and the % of GDP in Korea (Republic) in 2012?
Give a very brief answer. -13.98. What is the difference between the % of GDP of Belize in 2011 and the % of GDP of Oman in 2012?
Your answer should be compact. -7.82. What is the difference between the % of GDP in Belize in 2011 and the % of GDP in Timor-Leste in 2012?
Ensure brevity in your answer.  -38.43. What is the difference between the % of GDP in Korea (Republic) in 2011 and the % of GDP in Oman in 2012?
Offer a terse response. 8.12. What is the difference between the % of GDP of Korea (Republic) in 2011 and the % of GDP of Timor-Leste in 2012?
Provide a short and direct response. -22.49. What is the difference between the % of GDP in Oman in 2011 and the % of GDP in Timor-Leste in 2012?
Ensure brevity in your answer.  -31.64. What is the difference between the % of GDP of Belize in 2011 and the % of GDP of Korea (Republic) in 2013?
Your response must be concise. -12.08. What is the difference between the % of GDP of Belize in 2011 and the % of GDP of Oman in 2013?
Provide a short and direct response. -8.74. What is the difference between the % of GDP in Belize in 2011 and the % of GDP in Timor-Leste in 2013?
Make the answer very short. -22.1. What is the difference between the % of GDP in Korea (Republic) in 2011 and the % of GDP in Oman in 2013?
Provide a short and direct response. 7.2. What is the difference between the % of GDP in Korea (Republic) in 2011 and the % of GDP in Timor-Leste in 2013?
Offer a terse response. -6.16. What is the difference between the % of GDP of Oman in 2011 and the % of GDP of Timor-Leste in 2013?
Offer a terse response. -15.32. What is the difference between the % of GDP in Belize in 2012 and the % of GDP in Korea (Republic) in 2013?
Offer a terse response. -13.1. What is the difference between the % of GDP of Belize in 2012 and the % of GDP of Oman in 2013?
Offer a very short reply. -9.76. What is the difference between the % of GDP in Belize in 2012 and the % of GDP in Timor-Leste in 2013?
Provide a short and direct response. -23.12. What is the difference between the % of GDP of Korea (Republic) in 2012 and the % of GDP of Oman in 2013?
Provide a short and direct response. 5.24. What is the difference between the % of GDP of Korea (Republic) in 2012 and the % of GDP of Timor-Leste in 2013?
Keep it short and to the point. -8.12. What is the difference between the % of GDP in Oman in 2012 and the % of GDP in Timor-Leste in 2013?
Offer a terse response. -14.29. What is the average % of GDP of Belize per year?
Make the answer very short. 18.5. What is the average % of GDP of Korea (Republic) per year?
Keep it short and to the point. 31.48. What is the average % of GDP of Oman per year?
Provide a short and direct response. 28.24. What is the average % of GDP in Timor-Leste per year?
Ensure brevity in your answer.  38. In the year 2006, what is the difference between the % of GDP in Belize and % of GDP in Korea (Republic)?
Offer a terse response. -13.39. In the year 2006, what is the difference between the % of GDP in Belize and % of GDP in Oman?
Ensure brevity in your answer.  -7.84. In the year 2006, what is the difference between the % of GDP of Belize and % of GDP of Timor-Leste?
Provide a succinct answer. 6.35. In the year 2006, what is the difference between the % of GDP in Korea (Republic) and % of GDP in Oman?
Give a very brief answer. 5.55. In the year 2006, what is the difference between the % of GDP of Korea (Republic) and % of GDP of Timor-Leste?
Keep it short and to the point. 19.74. In the year 2006, what is the difference between the % of GDP in Oman and % of GDP in Timor-Leste?
Your answer should be compact. 14.19. In the year 2007, what is the difference between the % of GDP of Belize and % of GDP of Korea (Republic)?
Provide a succinct answer. -12.97. In the year 2007, what is the difference between the % of GDP of Belize and % of GDP of Oman?
Provide a short and direct response. -14.67. In the year 2007, what is the difference between the % of GDP in Belize and % of GDP in Timor-Leste?
Offer a very short reply. 1.54. In the year 2007, what is the difference between the % of GDP in Korea (Republic) and % of GDP in Oman?
Offer a terse response. -1.7. In the year 2007, what is the difference between the % of GDP of Korea (Republic) and % of GDP of Timor-Leste?
Your answer should be compact. 14.51. In the year 2007, what is the difference between the % of GDP of Oman and % of GDP of Timor-Leste?
Ensure brevity in your answer.  16.21. In the year 2008, what is the difference between the % of GDP in Belize and % of GDP in Korea (Republic)?
Provide a short and direct response. -7.43. In the year 2008, what is the difference between the % of GDP in Belize and % of GDP in Oman?
Make the answer very short. -10.9. In the year 2008, what is the difference between the % of GDP in Belize and % of GDP in Timor-Leste?
Give a very brief answer. -3.66. In the year 2008, what is the difference between the % of GDP of Korea (Republic) and % of GDP of Oman?
Offer a terse response. -3.47. In the year 2008, what is the difference between the % of GDP in Korea (Republic) and % of GDP in Timor-Leste?
Offer a terse response. 3.77. In the year 2008, what is the difference between the % of GDP in Oman and % of GDP in Timor-Leste?
Make the answer very short. 7.24. In the year 2009, what is the difference between the % of GDP of Belize and % of GDP of Korea (Republic)?
Keep it short and to the point. -9.39. In the year 2009, what is the difference between the % of GDP in Belize and % of GDP in Oman?
Ensure brevity in your answer.  -9.13. In the year 2009, what is the difference between the % of GDP of Belize and % of GDP of Timor-Leste?
Provide a succinct answer. -24.32. In the year 2009, what is the difference between the % of GDP in Korea (Republic) and % of GDP in Oman?
Your answer should be very brief. 0.26. In the year 2009, what is the difference between the % of GDP of Korea (Republic) and % of GDP of Timor-Leste?
Provide a succinct answer. -14.93. In the year 2009, what is the difference between the % of GDP of Oman and % of GDP of Timor-Leste?
Make the answer very short. -15.19. In the year 2010, what is the difference between the % of GDP of Belize and % of GDP of Korea (Republic)?
Keep it short and to the point. -18.8. In the year 2010, what is the difference between the % of GDP of Belize and % of GDP of Oman?
Provide a succinct answer. -12.19. In the year 2010, what is the difference between the % of GDP of Belize and % of GDP of Timor-Leste?
Your response must be concise. -26.82. In the year 2010, what is the difference between the % of GDP in Korea (Republic) and % of GDP in Oman?
Offer a very short reply. 6.6. In the year 2010, what is the difference between the % of GDP of Korea (Republic) and % of GDP of Timor-Leste?
Offer a very short reply. -8.02. In the year 2010, what is the difference between the % of GDP of Oman and % of GDP of Timor-Leste?
Provide a short and direct response. -14.62. In the year 2011, what is the difference between the % of GDP of Belize and % of GDP of Korea (Republic)?
Offer a terse response. -15.94. In the year 2011, what is the difference between the % of GDP of Belize and % of GDP of Oman?
Your answer should be compact. -6.79. In the year 2011, what is the difference between the % of GDP in Belize and % of GDP in Timor-Leste?
Provide a short and direct response. -48.71. In the year 2011, what is the difference between the % of GDP in Korea (Republic) and % of GDP in Oman?
Your answer should be very brief. 9.15. In the year 2011, what is the difference between the % of GDP in Korea (Republic) and % of GDP in Timor-Leste?
Offer a very short reply. -32.77. In the year 2011, what is the difference between the % of GDP of Oman and % of GDP of Timor-Leste?
Provide a succinct answer. -41.92. In the year 2012, what is the difference between the % of GDP of Belize and % of GDP of Korea (Republic)?
Provide a succinct answer. -15. In the year 2012, what is the difference between the % of GDP in Belize and % of GDP in Oman?
Make the answer very short. -8.83. In the year 2012, what is the difference between the % of GDP of Belize and % of GDP of Timor-Leste?
Your answer should be very brief. -39.44. In the year 2012, what is the difference between the % of GDP of Korea (Republic) and % of GDP of Oman?
Provide a short and direct response. 6.17. In the year 2012, what is the difference between the % of GDP in Korea (Republic) and % of GDP in Timor-Leste?
Provide a short and direct response. -24.44. In the year 2012, what is the difference between the % of GDP of Oman and % of GDP of Timor-Leste?
Offer a terse response. -30.61. In the year 2013, what is the difference between the % of GDP of Belize and % of GDP of Korea (Republic)?
Your response must be concise. -10.95. In the year 2013, what is the difference between the % of GDP in Belize and % of GDP in Oman?
Ensure brevity in your answer.  -7.61. In the year 2013, what is the difference between the % of GDP in Belize and % of GDP in Timor-Leste?
Provide a short and direct response. -20.97. In the year 2013, what is the difference between the % of GDP in Korea (Republic) and % of GDP in Oman?
Provide a short and direct response. 3.34. In the year 2013, what is the difference between the % of GDP in Korea (Republic) and % of GDP in Timor-Leste?
Offer a terse response. -10.02. In the year 2013, what is the difference between the % of GDP in Oman and % of GDP in Timor-Leste?
Ensure brevity in your answer.  -13.36. What is the ratio of the % of GDP in Belize in 2006 to that in 2007?
Give a very brief answer. 0.98. What is the ratio of the % of GDP in Oman in 2006 to that in 2007?
Your answer should be compact. 0.79. What is the ratio of the % of GDP in Timor-Leste in 2006 to that in 2007?
Provide a short and direct response. 0.72. What is the ratio of the % of GDP in Belize in 2006 to that in 2008?
Make the answer very short. 0.75. What is the ratio of the % of GDP of Oman in 2006 to that in 2008?
Keep it short and to the point. 0.74. What is the ratio of the % of GDP in Timor-Leste in 2006 to that in 2008?
Offer a terse response. 0.44. What is the ratio of the % of GDP in Belize in 2006 to that in 2009?
Make the answer very short. 1.01. What is the ratio of the % of GDP in Korea (Republic) in 2006 to that in 2009?
Provide a succinct answer. 1.15. What is the ratio of the % of GDP of Oman in 2006 to that in 2009?
Your answer should be compact. 0.96. What is the ratio of the % of GDP in Timor-Leste in 2006 to that in 2009?
Ensure brevity in your answer.  0.3. What is the ratio of the % of GDP in Belize in 2006 to that in 2010?
Offer a very short reply. 1.46. What is the ratio of the % of GDP in Korea (Republic) in 2006 to that in 2010?
Offer a very short reply. 1.02. What is the ratio of the % of GDP of Oman in 2006 to that in 2010?
Provide a succinct answer. 1.07. What is the ratio of the % of GDP of Timor-Leste in 2006 to that in 2010?
Provide a short and direct response. 0.32. What is the ratio of the % of GDP in Belize in 2006 to that in 2011?
Your response must be concise. 1.13. What is the ratio of the % of GDP in Oman in 2006 to that in 2011?
Provide a succinct answer. 1.14. What is the ratio of the % of GDP in Timor-Leste in 2006 to that in 2011?
Your answer should be compact. 0.2. What is the ratio of the % of GDP in Belize in 2006 to that in 2012?
Give a very brief answer. 1.21. What is the ratio of the % of GDP of Korea (Republic) in 2006 to that in 2012?
Give a very brief answer. 1.05. What is the ratio of the % of GDP in Oman in 2006 to that in 2012?
Provide a succinct answer. 1.09. What is the ratio of the % of GDP in Timor-Leste in 2006 to that in 2012?
Your answer should be compact. 0.23. What is the ratio of the % of GDP in Belize in 2006 to that in 2013?
Make the answer very short. 1.06. What is the ratio of the % of GDP in Korea (Republic) in 2006 to that in 2013?
Offer a terse response. 1.12. What is the ratio of the % of GDP of Oman in 2006 to that in 2013?
Keep it short and to the point. 1.05. What is the ratio of the % of GDP of Timor-Leste in 2006 to that in 2013?
Provide a short and direct response. 0.33. What is the ratio of the % of GDP in Belize in 2007 to that in 2008?
Keep it short and to the point. 0.77. What is the ratio of the % of GDP of Korea (Republic) in 2007 to that in 2008?
Provide a short and direct response. 0.99. What is the ratio of the % of GDP of Oman in 2007 to that in 2008?
Your response must be concise. 0.94. What is the ratio of the % of GDP of Timor-Leste in 2007 to that in 2008?
Give a very brief answer. 0.62. What is the ratio of the % of GDP in Belize in 2007 to that in 2009?
Your response must be concise. 1.03. What is the ratio of the % of GDP of Korea (Republic) in 2007 to that in 2009?
Keep it short and to the point. 1.14. What is the ratio of the % of GDP in Oman in 2007 to that in 2009?
Make the answer very short. 1.22. What is the ratio of the % of GDP in Timor-Leste in 2007 to that in 2009?
Ensure brevity in your answer.  0.42. What is the ratio of the % of GDP of Belize in 2007 to that in 2010?
Provide a short and direct response. 1.48. What is the ratio of the % of GDP in Korea (Republic) in 2007 to that in 2010?
Your answer should be very brief. 1.02. What is the ratio of the % of GDP of Oman in 2007 to that in 2010?
Make the answer very short. 1.35. What is the ratio of the % of GDP of Timor-Leste in 2007 to that in 2010?
Your response must be concise. 0.45. What is the ratio of the % of GDP of Belize in 2007 to that in 2011?
Ensure brevity in your answer.  1.15. What is the ratio of the % of GDP of Oman in 2007 to that in 2011?
Provide a short and direct response. 1.44. What is the ratio of the % of GDP of Timor-Leste in 2007 to that in 2011?
Your answer should be very brief. 0.27. What is the ratio of the % of GDP of Belize in 2007 to that in 2012?
Offer a terse response. 1.23. What is the ratio of the % of GDP of Korea (Republic) in 2007 to that in 2012?
Provide a succinct answer. 1.05. What is the ratio of the % of GDP of Oman in 2007 to that in 2012?
Provide a succinct answer. 1.38. What is the ratio of the % of GDP of Timor-Leste in 2007 to that in 2012?
Give a very brief answer. 0.33. What is the ratio of the % of GDP in Belize in 2007 to that in 2013?
Keep it short and to the point. 1.08. What is the ratio of the % of GDP of Korea (Republic) in 2007 to that in 2013?
Ensure brevity in your answer.  1.12. What is the ratio of the % of GDP of Oman in 2007 to that in 2013?
Ensure brevity in your answer.  1.33. What is the ratio of the % of GDP of Timor-Leste in 2007 to that in 2013?
Your response must be concise. 0.46. What is the ratio of the % of GDP of Belize in 2008 to that in 2009?
Offer a very short reply. 1.34. What is the ratio of the % of GDP in Korea (Republic) in 2008 to that in 2009?
Your answer should be very brief. 1.16. What is the ratio of the % of GDP of Oman in 2008 to that in 2009?
Make the answer very short. 1.29. What is the ratio of the % of GDP of Timor-Leste in 2008 to that in 2009?
Make the answer very short. 0.67. What is the ratio of the % of GDP in Belize in 2008 to that in 2010?
Offer a terse response. 1.94. What is the ratio of the % of GDP in Korea (Republic) in 2008 to that in 2010?
Ensure brevity in your answer.  1.03. What is the ratio of the % of GDP of Oman in 2008 to that in 2010?
Make the answer very short. 1.44. What is the ratio of the % of GDP in Timor-Leste in 2008 to that in 2010?
Your answer should be very brief. 0.73. What is the ratio of the % of GDP in Belize in 2008 to that in 2011?
Give a very brief answer. 1.5. What is the ratio of the % of GDP of Korea (Republic) in 2008 to that in 2011?
Keep it short and to the point. 1. What is the ratio of the % of GDP in Oman in 2008 to that in 2011?
Your response must be concise. 1.53. What is the ratio of the % of GDP in Timor-Leste in 2008 to that in 2011?
Ensure brevity in your answer.  0.45. What is the ratio of the % of GDP in Belize in 2008 to that in 2012?
Keep it short and to the point. 1.6. What is the ratio of the % of GDP of Korea (Republic) in 2008 to that in 2012?
Give a very brief answer. 1.07. What is the ratio of the % of GDP in Oman in 2008 to that in 2012?
Provide a succinct answer. 1.47. What is the ratio of the % of GDP in Timor-Leste in 2008 to that in 2012?
Your answer should be compact. 0.53. What is the ratio of the % of GDP of Belize in 2008 to that in 2013?
Your response must be concise. 1.41. What is the ratio of the % of GDP of Korea (Republic) in 2008 to that in 2013?
Keep it short and to the point. 1.13. What is the ratio of the % of GDP of Oman in 2008 to that in 2013?
Your response must be concise. 1.42. What is the ratio of the % of GDP in Timor-Leste in 2008 to that in 2013?
Give a very brief answer. 0.75. What is the ratio of the % of GDP of Belize in 2009 to that in 2010?
Offer a very short reply. 1.44. What is the ratio of the % of GDP of Korea (Republic) in 2009 to that in 2010?
Your answer should be compact. 0.89. What is the ratio of the % of GDP in Oman in 2009 to that in 2010?
Offer a terse response. 1.11. What is the ratio of the % of GDP of Timor-Leste in 2009 to that in 2010?
Offer a terse response. 1.08. What is the ratio of the % of GDP in Belize in 2009 to that in 2011?
Give a very brief answer. 1.12. What is the ratio of the % of GDP in Korea (Republic) in 2009 to that in 2011?
Keep it short and to the point. 0.86. What is the ratio of the % of GDP of Oman in 2009 to that in 2011?
Ensure brevity in your answer.  1.19. What is the ratio of the % of GDP of Timor-Leste in 2009 to that in 2011?
Offer a terse response. 0.66. What is the ratio of the % of GDP of Belize in 2009 to that in 2012?
Provide a short and direct response. 1.19. What is the ratio of the % of GDP in Korea (Republic) in 2009 to that in 2012?
Your response must be concise. 0.92. What is the ratio of the % of GDP of Oman in 2009 to that in 2012?
Offer a terse response. 1.14. What is the ratio of the % of GDP of Timor-Leste in 2009 to that in 2012?
Your answer should be very brief. 0.78. What is the ratio of the % of GDP in Belize in 2009 to that in 2013?
Make the answer very short. 1.05. What is the ratio of the % of GDP of Korea (Republic) in 2009 to that in 2013?
Your answer should be compact. 0.98. What is the ratio of the % of GDP of Oman in 2009 to that in 2013?
Your answer should be compact. 1.09. What is the ratio of the % of GDP in Timor-Leste in 2009 to that in 2013?
Offer a very short reply. 1.11. What is the ratio of the % of GDP in Belize in 2010 to that in 2011?
Offer a very short reply. 0.78. What is the ratio of the % of GDP of Korea (Republic) in 2010 to that in 2011?
Ensure brevity in your answer.  0.97. What is the ratio of the % of GDP in Oman in 2010 to that in 2011?
Offer a terse response. 1.07. What is the ratio of the % of GDP in Timor-Leste in 2010 to that in 2011?
Make the answer very short. 0.61. What is the ratio of the % of GDP in Belize in 2010 to that in 2012?
Keep it short and to the point. 0.83. What is the ratio of the % of GDP of Korea (Republic) in 2010 to that in 2012?
Make the answer very short. 1.03. What is the ratio of the % of GDP in Oman in 2010 to that in 2012?
Make the answer very short. 1.02. What is the ratio of the % of GDP of Timor-Leste in 2010 to that in 2012?
Make the answer very short. 0.72. What is the ratio of the % of GDP in Belize in 2010 to that in 2013?
Give a very brief answer. 0.73. What is the ratio of the % of GDP of Korea (Republic) in 2010 to that in 2013?
Offer a very short reply. 1.1. What is the ratio of the % of GDP of Timor-Leste in 2010 to that in 2013?
Provide a short and direct response. 1.02. What is the ratio of the % of GDP of Belize in 2011 to that in 2012?
Provide a short and direct response. 1.06. What is the ratio of the % of GDP in Korea (Republic) in 2011 to that in 2012?
Your answer should be very brief. 1.06. What is the ratio of the % of GDP of Oman in 2011 to that in 2012?
Offer a terse response. 0.96. What is the ratio of the % of GDP of Timor-Leste in 2011 to that in 2012?
Your answer should be compact. 1.19. What is the ratio of the % of GDP in Belize in 2011 to that in 2013?
Provide a short and direct response. 0.94. What is the ratio of the % of GDP in Korea (Republic) in 2011 to that in 2013?
Offer a very short reply. 1.13. What is the ratio of the % of GDP in Oman in 2011 to that in 2013?
Keep it short and to the point. 0.92. What is the ratio of the % of GDP of Timor-Leste in 2011 to that in 2013?
Give a very brief answer. 1.68. What is the ratio of the % of GDP of Belize in 2012 to that in 2013?
Your answer should be very brief. 0.88. What is the ratio of the % of GDP in Korea (Republic) in 2012 to that in 2013?
Your answer should be compact. 1.07. What is the ratio of the % of GDP in Oman in 2012 to that in 2013?
Ensure brevity in your answer.  0.96. What is the ratio of the % of GDP in Timor-Leste in 2012 to that in 2013?
Your answer should be very brief. 1.42. What is the difference between the highest and the second highest % of GDP of Belize?
Provide a succinct answer. 5.98. What is the difference between the highest and the second highest % of GDP in Korea (Republic)?
Ensure brevity in your answer.  0.06. What is the difference between the highest and the second highest % of GDP of Oman?
Your answer should be very brief. 2.21. What is the difference between the highest and the second highest % of GDP of Timor-Leste?
Make the answer very short. 10.29. What is the difference between the highest and the lowest % of GDP of Belize?
Offer a terse response. 12.37. What is the difference between the highest and the lowest % of GDP in Korea (Republic)?
Provide a succinct answer. 4.55. What is the difference between the highest and the lowest % of GDP of Oman?
Give a very brief answer. 12.68. What is the difference between the highest and the lowest % of GDP in Timor-Leste?
Make the answer very short. 52.77. 